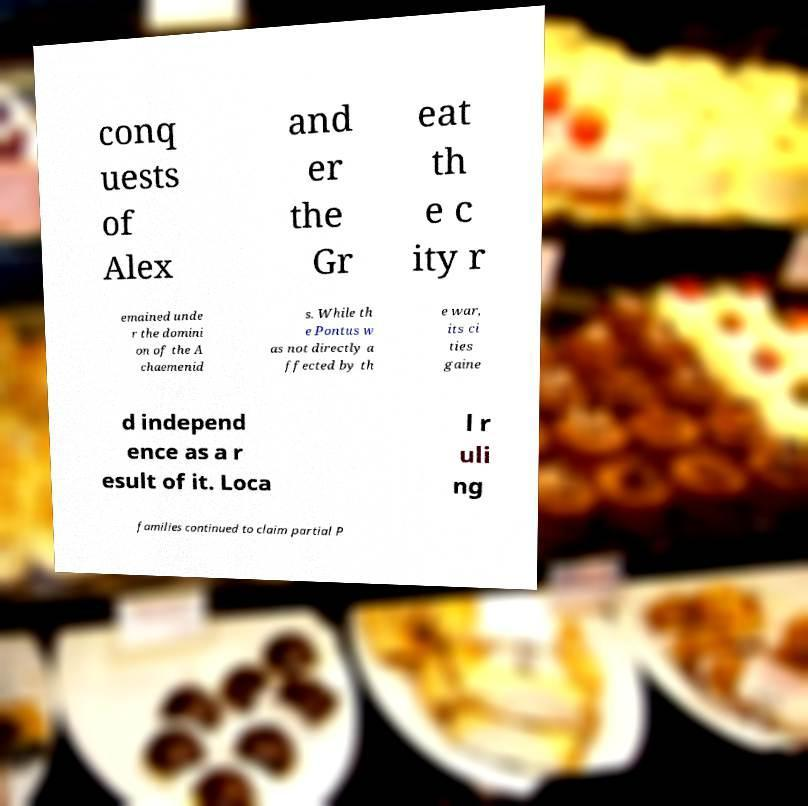For documentation purposes, I need the text within this image transcribed. Could you provide that? conq uests of Alex and er the Gr eat th e c ity r emained unde r the domini on of the A chaemenid s. While th e Pontus w as not directly a ffected by th e war, its ci ties gaine d independ ence as a r esult of it. Loca l r uli ng families continued to claim partial P 